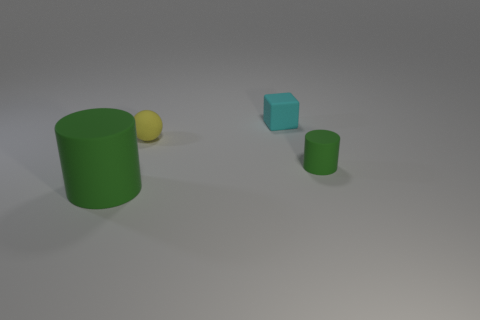What materials do the objects in the image seem to be made from? The objects in the image appear to have different materials. The cyan and the green objects have a matte, rubber-like texture, while the yellow sphere has a smoother, almost plastic-like surface. 